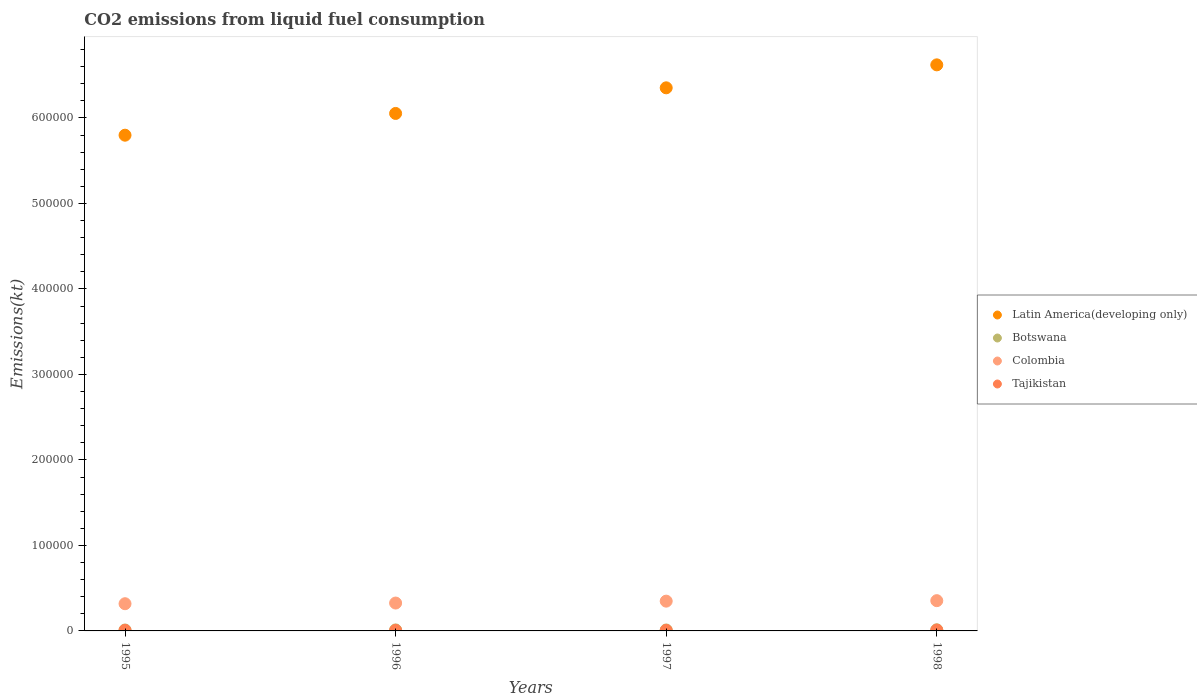Is the number of dotlines equal to the number of legend labels?
Provide a short and direct response. Yes. What is the amount of CO2 emitted in Botswana in 1997?
Your response must be concise. 1100.1. Across all years, what is the maximum amount of CO2 emitted in Colombia?
Offer a terse response. 3.54e+04. Across all years, what is the minimum amount of CO2 emitted in Latin America(developing only)?
Make the answer very short. 5.80e+05. In which year was the amount of CO2 emitted in Tajikistan minimum?
Provide a succinct answer. 1996. What is the total amount of CO2 emitted in Latin America(developing only) in the graph?
Ensure brevity in your answer.  2.48e+06. What is the difference between the amount of CO2 emitted in Colombia in 1995 and that in 1997?
Provide a succinct answer. -3006.94. What is the difference between the amount of CO2 emitted in Colombia in 1998 and the amount of CO2 emitted in Tajikistan in 1997?
Give a very brief answer. 3.48e+04. What is the average amount of CO2 emitted in Colombia per year?
Your response must be concise. 3.37e+04. In the year 1997, what is the difference between the amount of CO2 emitted in Tajikistan and amount of CO2 emitted in Botswana?
Offer a terse response. -469.38. What is the ratio of the amount of CO2 emitted in Latin America(developing only) in 1996 to that in 1997?
Your answer should be compact. 0.95. Is the amount of CO2 emitted in Tajikistan in 1996 less than that in 1997?
Give a very brief answer. No. What is the difference between the highest and the second highest amount of CO2 emitted in Latin America(developing only)?
Offer a terse response. 2.69e+04. What is the difference between the highest and the lowest amount of CO2 emitted in Colombia?
Your answer should be very brief. 3567.99. Is it the case that in every year, the sum of the amount of CO2 emitted in Colombia and amount of CO2 emitted in Tajikistan  is greater than the amount of CO2 emitted in Botswana?
Your response must be concise. Yes. Is the amount of CO2 emitted in Tajikistan strictly less than the amount of CO2 emitted in Colombia over the years?
Provide a short and direct response. Yes. Are the values on the major ticks of Y-axis written in scientific E-notation?
Your answer should be compact. No. Does the graph contain any zero values?
Make the answer very short. No. Does the graph contain grids?
Offer a terse response. No. How are the legend labels stacked?
Provide a succinct answer. Vertical. What is the title of the graph?
Your answer should be very brief. CO2 emissions from liquid fuel consumption. What is the label or title of the X-axis?
Keep it short and to the point. Years. What is the label or title of the Y-axis?
Provide a short and direct response. Emissions(kt). What is the Emissions(kt) in Latin America(developing only) in 1995?
Keep it short and to the point. 5.80e+05. What is the Emissions(kt) in Botswana in 1995?
Ensure brevity in your answer.  1070.76. What is the Emissions(kt) in Colombia in 1995?
Provide a short and direct response. 3.18e+04. What is the Emissions(kt) of Tajikistan in 1995?
Your answer should be very brief. 671.06. What is the Emissions(kt) of Latin America(developing only) in 1996?
Your answer should be compact. 6.05e+05. What is the Emissions(kt) in Botswana in 1996?
Provide a succinct answer. 1169.77. What is the Emissions(kt) in Colombia in 1996?
Your answer should be compact. 3.26e+04. What is the Emissions(kt) of Tajikistan in 1996?
Make the answer very short. 630.72. What is the Emissions(kt) of Latin America(developing only) in 1997?
Offer a terse response. 6.35e+05. What is the Emissions(kt) in Botswana in 1997?
Your answer should be compact. 1100.1. What is the Emissions(kt) in Colombia in 1997?
Ensure brevity in your answer.  3.48e+04. What is the Emissions(kt) of Tajikistan in 1997?
Make the answer very short. 630.72. What is the Emissions(kt) in Latin America(developing only) in 1998?
Give a very brief answer. 6.62e+05. What is the Emissions(kt) of Botswana in 1998?
Offer a very short reply. 1320.12. What is the Emissions(kt) of Colombia in 1998?
Provide a short and direct response. 3.54e+04. What is the Emissions(kt) of Tajikistan in 1998?
Your answer should be compact. 968.09. Across all years, what is the maximum Emissions(kt) of Latin America(developing only)?
Keep it short and to the point. 6.62e+05. Across all years, what is the maximum Emissions(kt) in Botswana?
Your answer should be very brief. 1320.12. Across all years, what is the maximum Emissions(kt) in Colombia?
Your answer should be compact. 3.54e+04. Across all years, what is the maximum Emissions(kt) in Tajikistan?
Give a very brief answer. 968.09. Across all years, what is the minimum Emissions(kt) of Latin America(developing only)?
Give a very brief answer. 5.80e+05. Across all years, what is the minimum Emissions(kt) in Botswana?
Offer a terse response. 1070.76. Across all years, what is the minimum Emissions(kt) in Colombia?
Make the answer very short. 3.18e+04. Across all years, what is the minimum Emissions(kt) of Tajikistan?
Keep it short and to the point. 630.72. What is the total Emissions(kt) in Latin America(developing only) in the graph?
Give a very brief answer. 2.48e+06. What is the total Emissions(kt) of Botswana in the graph?
Your answer should be compact. 4660.76. What is the total Emissions(kt) in Colombia in the graph?
Make the answer very short. 1.35e+05. What is the total Emissions(kt) in Tajikistan in the graph?
Make the answer very short. 2900.6. What is the difference between the Emissions(kt) in Latin America(developing only) in 1995 and that in 1996?
Make the answer very short. -2.54e+04. What is the difference between the Emissions(kt) of Botswana in 1995 and that in 1996?
Your answer should be very brief. -99.01. What is the difference between the Emissions(kt) of Colombia in 1995 and that in 1996?
Provide a short and direct response. -784.74. What is the difference between the Emissions(kt) in Tajikistan in 1995 and that in 1996?
Offer a terse response. 40.34. What is the difference between the Emissions(kt) of Latin America(developing only) in 1995 and that in 1997?
Offer a very short reply. -5.54e+04. What is the difference between the Emissions(kt) in Botswana in 1995 and that in 1997?
Keep it short and to the point. -29.34. What is the difference between the Emissions(kt) of Colombia in 1995 and that in 1997?
Offer a very short reply. -3006.94. What is the difference between the Emissions(kt) in Tajikistan in 1995 and that in 1997?
Provide a short and direct response. 40.34. What is the difference between the Emissions(kt) of Latin America(developing only) in 1995 and that in 1998?
Make the answer very short. -8.23e+04. What is the difference between the Emissions(kt) of Botswana in 1995 and that in 1998?
Provide a succinct answer. -249.36. What is the difference between the Emissions(kt) of Colombia in 1995 and that in 1998?
Your answer should be very brief. -3567.99. What is the difference between the Emissions(kt) of Tajikistan in 1995 and that in 1998?
Offer a very short reply. -297.03. What is the difference between the Emissions(kt) in Latin America(developing only) in 1996 and that in 1997?
Your answer should be very brief. -3.00e+04. What is the difference between the Emissions(kt) in Botswana in 1996 and that in 1997?
Provide a short and direct response. 69.67. What is the difference between the Emissions(kt) of Colombia in 1996 and that in 1997?
Keep it short and to the point. -2222.2. What is the difference between the Emissions(kt) in Tajikistan in 1996 and that in 1997?
Your response must be concise. 0. What is the difference between the Emissions(kt) of Latin America(developing only) in 1996 and that in 1998?
Offer a very short reply. -5.68e+04. What is the difference between the Emissions(kt) of Botswana in 1996 and that in 1998?
Make the answer very short. -150.35. What is the difference between the Emissions(kt) of Colombia in 1996 and that in 1998?
Ensure brevity in your answer.  -2783.25. What is the difference between the Emissions(kt) in Tajikistan in 1996 and that in 1998?
Offer a very short reply. -337.36. What is the difference between the Emissions(kt) of Latin America(developing only) in 1997 and that in 1998?
Offer a very short reply. -2.69e+04. What is the difference between the Emissions(kt) in Botswana in 1997 and that in 1998?
Ensure brevity in your answer.  -220.02. What is the difference between the Emissions(kt) in Colombia in 1997 and that in 1998?
Your answer should be very brief. -561.05. What is the difference between the Emissions(kt) in Tajikistan in 1997 and that in 1998?
Your answer should be very brief. -337.36. What is the difference between the Emissions(kt) in Latin America(developing only) in 1995 and the Emissions(kt) in Botswana in 1996?
Provide a succinct answer. 5.79e+05. What is the difference between the Emissions(kt) of Latin America(developing only) in 1995 and the Emissions(kt) of Colombia in 1996?
Make the answer very short. 5.47e+05. What is the difference between the Emissions(kt) in Latin America(developing only) in 1995 and the Emissions(kt) in Tajikistan in 1996?
Provide a short and direct response. 5.79e+05. What is the difference between the Emissions(kt) of Botswana in 1995 and the Emissions(kt) of Colombia in 1996?
Your response must be concise. -3.15e+04. What is the difference between the Emissions(kt) in Botswana in 1995 and the Emissions(kt) in Tajikistan in 1996?
Your answer should be compact. 440.04. What is the difference between the Emissions(kt) in Colombia in 1995 and the Emissions(kt) in Tajikistan in 1996?
Give a very brief answer. 3.12e+04. What is the difference between the Emissions(kt) of Latin America(developing only) in 1995 and the Emissions(kt) of Botswana in 1997?
Your answer should be very brief. 5.79e+05. What is the difference between the Emissions(kt) of Latin America(developing only) in 1995 and the Emissions(kt) of Colombia in 1997?
Provide a succinct answer. 5.45e+05. What is the difference between the Emissions(kt) of Latin America(developing only) in 1995 and the Emissions(kt) of Tajikistan in 1997?
Offer a very short reply. 5.79e+05. What is the difference between the Emissions(kt) in Botswana in 1995 and the Emissions(kt) in Colombia in 1997?
Your response must be concise. -3.38e+04. What is the difference between the Emissions(kt) of Botswana in 1995 and the Emissions(kt) of Tajikistan in 1997?
Your response must be concise. 440.04. What is the difference between the Emissions(kt) in Colombia in 1995 and the Emissions(kt) in Tajikistan in 1997?
Provide a short and direct response. 3.12e+04. What is the difference between the Emissions(kt) of Latin America(developing only) in 1995 and the Emissions(kt) of Botswana in 1998?
Your answer should be compact. 5.79e+05. What is the difference between the Emissions(kt) of Latin America(developing only) in 1995 and the Emissions(kt) of Colombia in 1998?
Keep it short and to the point. 5.44e+05. What is the difference between the Emissions(kt) of Latin America(developing only) in 1995 and the Emissions(kt) of Tajikistan in 1998?
Provide a succinct answer. 5.79e+05. What is the difference between the Emissions(kt) of Botswana in 1995 and the Emissions(kt) of Colombia in 1998?
Give a very brief answer. -3.43e+04. What is the difference between the Emissions(kt) of Botswana in 1995 and the Emissions(kt) of Tajikistan in 1998?
Your answer should be very brief. 102.68. What is the difference between the Emissions(kt) in Colombia in 1995 and the Emissions(kt) in Tajikistan in 1998?
Offer a terse response. 3.09e+04. What is the difference between the Emissions(kt) of Latin America(developing only) in 1996 and the Emissions(kt) of Botswana in 1997?
Keep it short and to the point. 6.04e+05. What is the difference between the Emissions(kt) in Latin America(developing only) in 1996 and the Emissions(kt) in Colombia in 1997?
Provide a succinct answer. 5.70e+05. What is the difference between the Emissions(kt) of Latin America(developing only) in 1996 and the Emissions(kt) of Tajikistan in 1997?
Your answer should be compact. 6.05e+05. What is the difference between the Emissions(kt) in Botswana in 1996 and the Emissions(kt) in Colombia in 1997?
Your answer should be very brief. -3.37e+04. What is the difference between the Emissions(kt) in Botswana in 1996 and the Emissions(kt) in Tajikistan in 1997?
Ensure brevity in your answer.  539.05. What is the difference between the Emissions(kt) of Colombia in 1996 and the Emissions(kt) of Tajikistan in 1997?
Provide a succinct answer. 3.20e+04. What is the difference between the Emissions(kt) of Latin America(developing only) in 1996 and the Emissions(kt) of Botswana in 1998?
Provide a short and direct response. 6.04e+05. What is the difference between the Emissions(kt) in Latin America(developing only) in 1996 and the Emissions(kt) in Colombia in 1998?
Offer a very short reply. 5.70e+05. What is the difference between the Emissions(kt) in Latin America(developing only) in 1996 and the Emissions(kt) in Tajikistan in 1998?
Your answer should be very brief. 6.04e+05. What is the difference between the Emissions(kt) in Botswana in 1996 and the Emissions(kt) in Colombia in 1998?
Provide a short and direct response. -3.42e+04. What is the difference between the Emissions(kt) in Botswana in 1996 and the Emissions(kt) in Tajikistan in 1998?
Give a very brief answer. 201.69. What is the difference between the Emissions(kt) of Colombia in 1996 and the Emissions(kt) of Tajikistan in 1998?
Give a very brief answer. 3.16e+04. What is the difference between the Emissions(kt) in Latin America(developing only) in 1997 and the Emissions(kt) in Botswana in 1998?
Keep it short and to the point. 6.34e+05. What is the difference between the Emissions(kt) in Latin America(developing only) in 1997 and the Emissions(kt) in Colombia in 1998?
Your answer should be very brief. 6.00e+05. What is the difference between the Emissions(kt) in Latin America(developing only) in 1997 and the Emissions(kt) in Tajikistan in 1998?
Make the answer very short. 6.34e+05. What is the difference between the Emissions(kt) of Botswana in 1997 and the Emissions(kt) of Colombia in 1998?
Offer a terse response. -3.43e+04. What is the difference between the Emissions(kt) in Botswana in 1997 and the Emissions(kt) in Tajikistan in 1998?
Provide a short and direct response. 132.01. What is the difference between the Emissions(kt) in Colombia in 1997 and the Emissions(kt) in Tajikistan in 1998?
Your response must be concise. 3.39e+04. What is the average Emissions(kt) in Latin America(developing only) per year?
Keep it short and to the point. 6.21e+05. What is the average Emissions(kt) of Botswana per year?
Ensure brevity in your answer.  1165.19. What is the average Emissions(kt) in Colombia per year?
Your answer should be very brief. 3.37e+04. What is the average Emissions(kt) of Tajikistan per year?
Offer a very short reply. 725.15. In the year 1995, what is the difference between the Emissions(kt) in Latin America(developing only) and Emissions(kt) in Botswana?
Ensure brevity in your answer.  5.79e+05. In the year 1995, what is the difference between the Emissions(kt) of Latin America(developing only) and Emissions(kt) of Colombia?
Keep it short and to the point. 5.48e+05. In the year 1995, what is the difference between the Emissions(kt) of Latin America(developing only) and Emissions(kt) of Tajikistan?
Your answer should be very brief. 5.79e+05. In the year 1995, what is the difference between the Emissions(kt) of Botswana and Emissions(kt) of Colombia?
Your answer should be compact. -3.07e+04. In the year 1995, what is the difference between the Emissions(kt) in Botswana and Emissions(kt) in Tajikistan?
Your answer should be compact. 399.7. In the year 1995, what is the difference between the Emissions(kt) of Colombia and Emissions(kt) of Tajikistan?
Your response must be concise. 3.11e+04. In the year 1996, what is the difference between the Emissions(kt) of Latin America(developing only) and Emissions(kt) of Botswana?
Your response must be concise. 6.04e+05. In the year 1996, what is the difference between the Emissions(kt) of Latin America(developing only) and Emissions(kt) of Colombia?
Make the answer very short. 5.73e+05. In the year 1996, what is the difference between the Emissions(kt) in Latin America(developing only) and Emissions(kt) in Tajikistan?
Keep it short and to the point. 6.05e+05. In the year 1996, what is the difference between the Emissions(kt) in Botswana and Emissions(kt) in Colombia?
Ensure brevity in your answer.  -3.14e+04. In the year 1996, what is the difference between the Emissions(kt) of Botswana and Emissions(kt) of Tajikistan?
Give a very brief answer. 539.05. In the year 1996, what is the difference between the Emissions(kt) in Colombia and Emissions(kt) in Tajikistan?
Provide a succinct answer. 3.20e+04. In the year 1997, what is the difference between the Emissions(kt) of Latin America(developing only) and Emissions(kt) of Botswana?
Offer a terse response. 6.34e+05. In the year 1997, what is the difference between the Emissions(kt) in Latin America(developing only) and Emissions(kt) in Colombia?
Provide a short and direct response. 6.00e+05. In the year 1997, what is the difference between the Emissions(kt) in Latin America(developing only) and Emissions(kt) in Tajikistan?
Keep it short and to the point. 6.35e+05. In the year 1997, what is the difference between the Emissions(kt) of Botswana and Emissions(kt) of Colombia?
Offer a terse response. -3.37e+04. In the year 1997, what is the difference between the Emissions(kt) in Botswana and Emissions(kt) in Tajikistan?
Make the answer very short. 469.38. In the year 1997, what is the difference between the Emissions(kt) in Colombia and Emissions(kt) in Tajikistan?
Offer a very short reply. 3.42e+04. In the year 1998, what is the difference between the Emissions(kt) of Latin America(developing only) and Emissions(kt) of Botswana?
Provide a succinct answer. 6.61e+05. In the year 1998, what is the difference between the Emissions(kt) of Latin America(developing only) and Emissions(kt) of Colombia?
Your response must be concise. 6.27e+05. In the year 1998, what is the difference between the Emissions(kt) of Latin America(developing only) and Emissions(kt) of Tajikistan?
Your response must be concise. 6.61e+05. In the year 1998, what is the difference between the Emissions(kt) of Botswana and Emissions(kt) of Colombia?
Give a very brief answer. -3.41e+04. In the year 1998, what is the difference between the Emissions(kt) of Botswana and Emissions(kt) of Tajikistan?
Offer a very short reply. 352.03. In the year 1998, what is the difference between the Emissions(kt) in Colombia and Emissions(kt) in Tajikistan?
Provide a succinct answer. 3.44e+04. What is the ratio of the Emissions(kt) of Latin America(developing only) in 1995 to that in 1996?
Provide a succinct answer. 0.96. What is the ratio of the Emissions(kt) of Botswana in 1995 to that in 1996?
Keep it short and to the point. 0.92. What is the ratio of the Emissions(kt) in Colombia in 1995 to that in 1996?
Your answer should be very brief. 0.98. What is the ratio of the Emissions(kt) of Tajikistan in 1995 to that in 1996?
Your answer should be very brief. 1.06. What is the ratio of the Emissions(kt) of Latin America(developing only) in 1995 to that in 1997?
Keep it short and to the point. 0.91. What is the ratio of the Emissions(kt) of Botswana in 1995 to that in 1997?
Provide a short and direct response. 0.97. What is the ratio of the Emissions(kt) of Colombia in 1995 to that in 1997?
Ensure brevity in your answer.  0.91. What is the ratio of the Emissions(kt) in Tajikistan in 1995 to that in 1997?
Provide a succinct answer. 1.06. What is the ratio of the Emissions(kt) of Latin America(developing only) in 1995 to that in 1998?
Make the answer very short. 0.88. What is the ratio of the Emissions(kt) in Botswana in 1995 to that in 1998?
Offer a very short reply. 0.81. What is the ratio of the Emissions(kt) in Colombia in 1995 to that in 1998?
Give a very brief answer. 0.9. What is the ratio of the Emissions(kt) in Tajikistan in 1995 to that in 1998?
Ensure brevity in your answer.  0.69. What is the ratio of the Emissions(kt) in Latin America(developing only) in 1996 to that in 1997?
Offer a very short reply. 0.95. What is the ratio of the Emissions(kt) in Botswana in 1996 to that in 1997?
Provide a short and direct response. 1.06. What is the ratio of the Emissions(kt) in Colombia in 1996 to that in 1997?
Make the answer very short. 0.94. What is the ratio of the Emissions(kt) in Latin America(developing only) in 1996 to that in 1998?
Provide a short and direct response. 0.91. What is the ratio of the Emissions(kt) of Botswana in 1996 to that in 1998?
Keep it short and to the point. 0.89. What is the ratio of the Emissions(kt) of Colombia in 1996 to that in 1998?
Give a very brief answer. 0.92. What is the ratio of the Emissions(kt) of Tajikistan in 1996 to that in 1998?
Offer a terse response. 0.65. What is the ratio of the Emissions(kt) in Latin America(developing only) in 1997 to that in 1998?
Give a very brief answer. 0.96. What is the ratio of the Emissions(kt) of Botswana in 1997 to that in 1998?
Your response must be concise. 0.83. What is the ratio of the Emissions(kt) of Colombia in 1997 to that in 1998?
Provide a short and direct response. 0.98. What is the ratio of the Emissions(kt) of Tajikistan in 1997 to that in 1998?
Your response must be concise. 0.65. What is the difference between the highest and the second highest Emissions(kt) of Latin America(developing only)?
Keep it short and to the point. 2.69e+04. What is the difference between the highest and the second highest Emissions(kt) in Botswana?
Provide a succinct answer. 150.35. What is the difference between the highest and the second highest Emissions(kt) in Colombia?
Provide a succinct answer. 561.05. What is the difference between the highest and the second highest Emissions(kt) of Tajikistan?
Your answer should be compact. 297.03. What is the difference between the highest and the lowest Emissions(kt) in Latin America(developing only)?
Provide a short and direct response. 8.23e+04. What is the difference between the highest and the lowest Emissions(kt) of Botswana?
Give a very brief answer. 249.36. What is the difference between the highest and the lowest Emissions(kt) in Colombia?
Your answer should be compact. 3567.99. What is the difference between the highest and the lowest Emissions(kt) in Tajikistan?
Your answer should be compact. 337.36. 